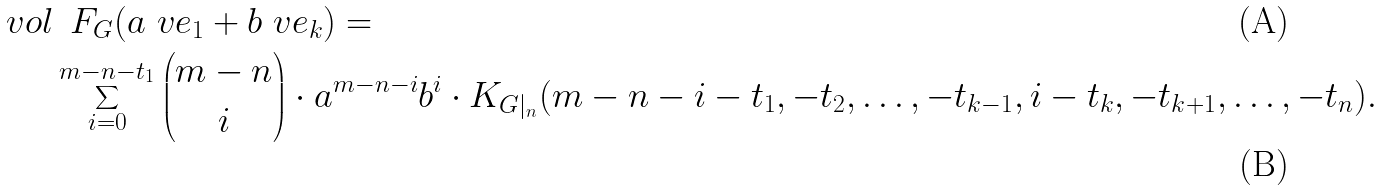Convert formula to latex. <formula><loc_0><loc_0><loc_500><loc_500>\ v o l & \, \ F _ { G } ( a \ v e _ { 1 } + b \ v e _ { k } ) = \\ & \sum _ { i = 0 } ^ { m - n - t _ { 1 } } \binom { m - n } { i } \cdot a ^ { m - n - i } b ^ { i } \cdot K _ { G | _ { n } } ( m - n - i - t _ { 1 } , - t _ { 2 } , \dots , - t _ { k - 1 } , i - t _ { k } , - t _ { k + 1 } , \dots , - t _ { n } ) .</formula> 